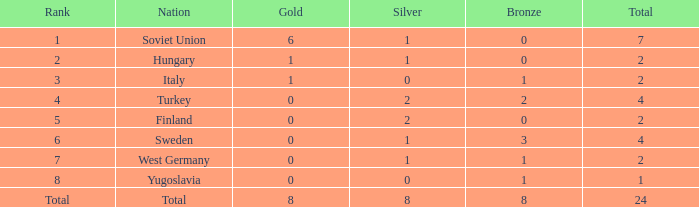What will be the combined sum when silver has a value of 0 and gold has a value of 1? 2.0. 